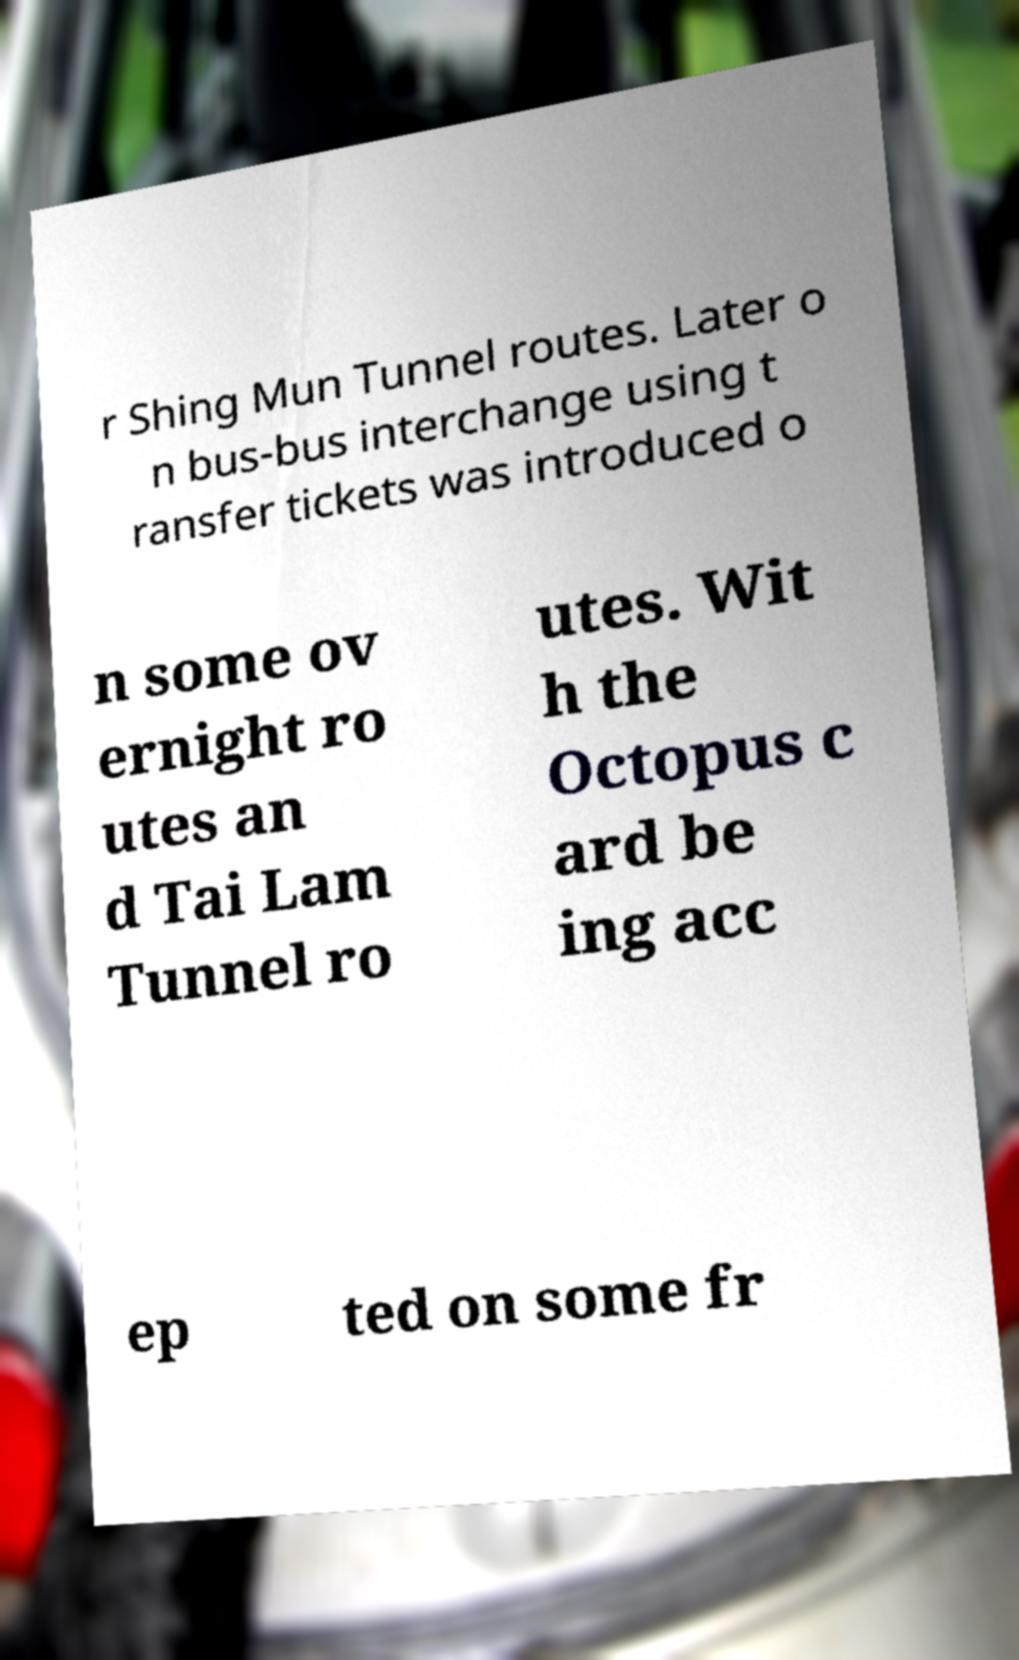Could you extract and type out the text from this image? r Shing Mun Tunnel routes. Later o n bus-bus interchange using t ransfer tickets was introduced o n some ov ernight ro utes an d Tai Lam Tunnel ro utes. Wit h the Octopus c ard be ing acc ep ted on some fr 